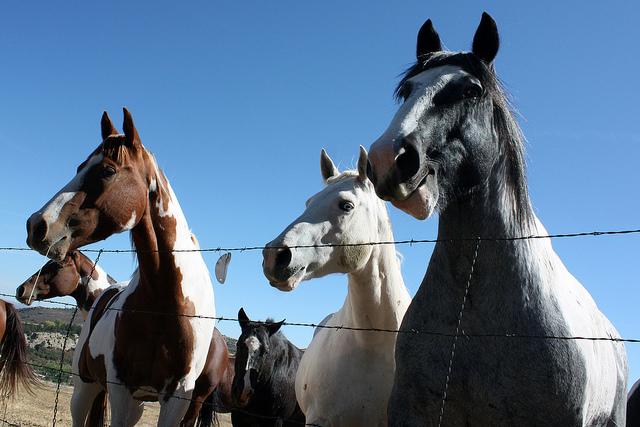How many of the horses are not white?
Write a very short answer. 5. How many horses have a white stripe going down their faces?
Concise answer only. 2. How many horses are visible?
Answer briefly. 6. Sunny or overcast?
Answer briefly. Sunny. 